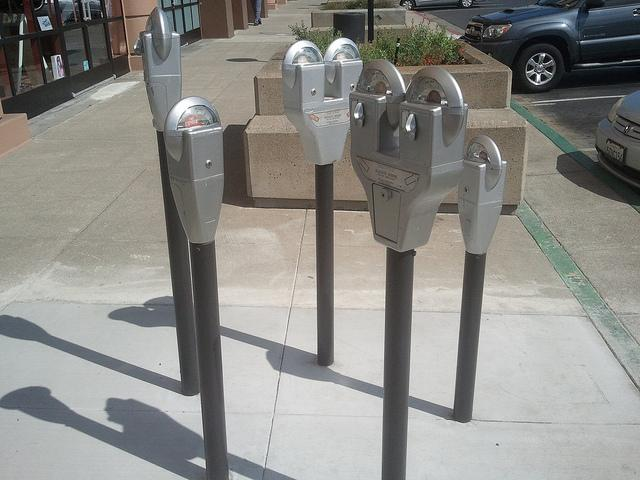How many cars do these meters currently monitor? seven 